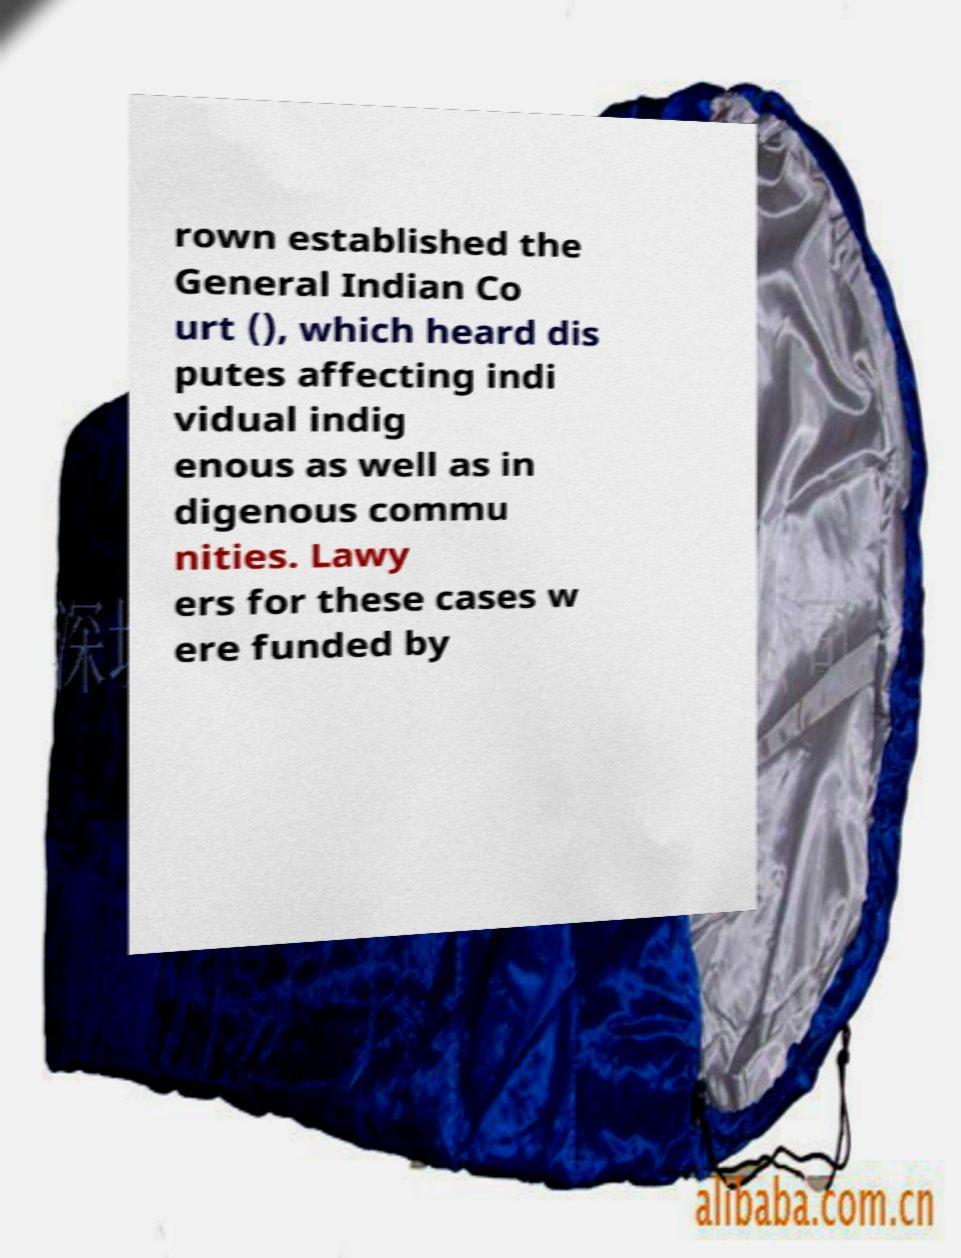Can you read and provide the text displayed in the image?This photo seems to have some interesting text. Can you extract and type it out for me? rown established the General Indian Co urt (), which heard dis putes affecting indi vidual indig enous as well as in digenous commu nities. Lawy ers for these cases w ere funded by 